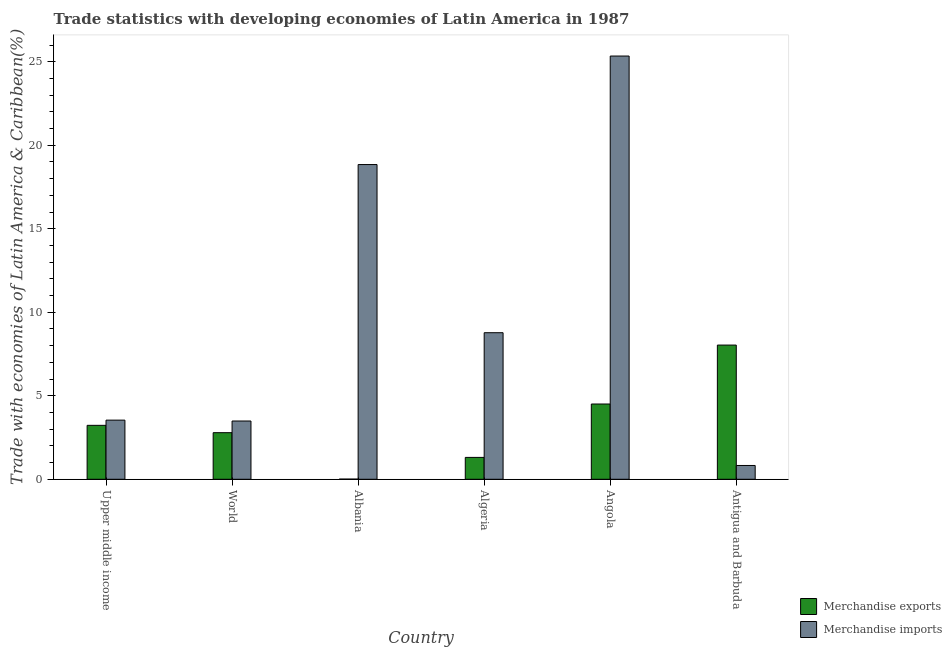How many different coloured bars are there?
Your answer should be very brief. 2. How many groups of bars are there?
Offer a terse response. 6. Are the number of bars per tick equal to the number of legend labels?
Provide a succinct answer. Yes. How many bars are there on the 2nd tick from the left?
Provide a succinct answer. 2. How many bars are there on the 6th tick from the right?
Provide a succinct answer. 2. What is the label of the 6th group of bars from the left?
Give a very brief answer. Antigua and Barbuda. What is the merchandise imports in Antigua and Barbuda?
Keep it short and to the point. 0.83. Across all countries, what is the maximum merchandise exports?
Offer a terse response. 8.04. Across all countries, what is the minimum merchandise exports?
Give a very brief answer. 0.01. In which country was the merchandise imports maximum?
Keep it short and to the point. Angola. In which country was the merchandise exports minimum?
Provide a short and direct response. Albania. What is the total merchandise exports in the graph?
Keep it short and to the point. 19.88. What is the difference between the merchandise exports in Angola and that in Antigua and Barbuda?
Make the answer very short. -3.53. What is the difference between the merchandise exports in Albania and the merchandise imports in World?
Provide a short and direct response. -3.48. What is the average merchandise exports per country?
Provide a succinct answer. 3.31. What is the difference between the merchandise imports and merchandise exports in Algeria?
Keep it short and to the point. 7.47. What is the ratio of the merchandise imports in Albania to that in Algeria?
Ensure brevity in your answer.  2.15. Is the difference between the merchandise exports in Algeria and Upper middle income greater than the difference between the merchandise imports in Algeria and Upper middle income?
Your response must be concise. No. What is the difference between the highest and the second highest merchandise imports?
Give a very brief answer. 6.5. What is the difference between the highest and the lowest merchandise imports?
Keep it short and to the point. 24.51. In how many countries, is the merchandise exports greater than the average merchandise exports taken over all countries?
Offer a very short reply. 2. What is the difference between two consecutive major ticks on the Y-axis?
Give a very brief answer. 5. Are the values on the major ticks of Y-axis written in scientific E-notation?
Your answer should be very brief. No. Does the graph contain grids?
Offer a very short reply. No. Where does the legend appear in the graph?
Your answer should be very brief. Bottom right. How many legend labels are there?
Your answer should be very brief. 2. What is the title of the graph?
Your response must be concise. Trade statistics with developing economies of Latin America in 1987. Does "Urban Population" appear as one of the legend labels in the graph?
Your answer should be compact. No. What is the label or title of the X-axis?
Keep it short and to the point. Country. What is the label or title of the Y-axis?
Offer a very short reply. Trade with economies of Latin America & Caribbean(%). What is the Trade with economies of Latin America & Caribbean(%) in Merchandise exports in Upper middle income?
Your response must be concise. 3.23. What is the Trade with economies of Latin America & Caribbean(%) in Merchandise imports in Upper middle income?
Your answer should be very brief. 3.54. What is the Trade with economies of Latin America & Caribbean(%) in Merchandise exports in World?
Your response must be concise. 2.79. What is the Trade with economies of Latin America & Caribbean(%) in Merchandise imports in World?
Offer a terse response. 3.49. What is the Trade with economies of Latin America & Caribbean(%) of Merchandise exports in Albania?
Offer a very short reply. 0.01. What is the Trade with economies of Latin America & Caribbean(%) of Merchandise imports in Albania?
Provide a succinct answer. 18.84. What is the Trade with economies of Latin America & Caribbean(%) in Merchandise exports in Algeria?
Give a very brief answer. 1.31. What is the Trade with economies of Latin America & Caribbean(%) in Merchandise imports in Algeria?
Offer a terse response. 8.77. What is the Trade with economies of Latin America & Caribbean(%) in Merchandise exports in Angola?
Offer a terse response. 4.51. What is the Trade with economies of Latin America & Caribbean(%) of Merchandise imports in Angola?
Make the answer very short. 25.34. What is the Trade with economies of Latin America & Caribbean(%) of Merchandise exports in Antigua and Barbuda?
Make the answer very short. 8.04. What is the Trade with economies of Latin America & Caribbean(%) in Merchandise imports in Antigua and Barbuda?
Make the answer very short. 0.83. Across all countries, what is the maximum Trade with economies of Latin America & Caribbean(%) of Merchandise exports?
Provide a succinct answer. 8.04. Across all countries, what is the maximum Trade with economies of Latin America & Caribbean(%) in Merchandise imports?
Your answer should be very brief. 25.34. Across all countries, what is the minimum Trade with economies of Latin America & Caribbean(%) in Merchandise exports?
Offer a terse response. 0.01. Across all countries, what is the minimum Trade with economies of Latin America & Caribbean(%) in Merchandise imports?
Keep it short and to the point. 0.83. What is the total Trade with economies of Latin America & Caribbean(%) in Merchandise exports in the graph?
Make the answer very short. 19.88. What is the total Trade with economies of Latin America & Caribbean(%) of Merchandise imports in the graph?
Ensure brevity in your answer.  60.81. What is the difference between the Trade with economies of Latin America & Caribbean(%) of Merchandise exports in Upper middle income and that in World?
Make the answer very short. 0.44. What is the difference between the Trade with economies of Latin America & Caribbean(%) in Merchandise imports in Upper middle income and that in World?
Offer a very short reply. 0.05. What is the difference between the Trade with economies of Latin America & Caribbean(%) of Merchandise exports in Upper middle income and that in Albania?
Your response must be concise. 3.22. What is the difference between the Trade with economies of Latin America & Caribbean(%) in Merchandise imports in Upper middle income and that in Albania?
Give a very brief answer. -15.3. What is the difference between the Trade with economies of Latin America & Caribbean(%) of Merchandise exports in Upper middle income and that in Algeria?
Offer a very short reply. 1.92. What is the difference between the Trade with economies of Latin America & Caribbean(%) of Merchandise imports in Upper middle income and that in Algeria?
Make the answer very short. -5.23. What is the difference between the Trade with economies of Latin America & Caribbean(%) in Merchandise exports in Upper middle income and that in Angola?
Your answer should be very brief. -1.28. What is the difference between the Trade with economies of Latin America & Caribbean(%) in Merchandise imports in Upper middle income and that in Angola?
Your answer should be very brief. -21.8. What is the difference between the Trade with economies of Latin America & Caribbean(%) of Merchandise exports in Upper middle income and that in Antigua and Barbuda?
Keep it short and to the point. -4.81. What is the difference between the Trade with economies of Latin America & Caribbean(%) in Merchandise imports in Upper middle income and that in Antigua and Barbuda?
Your answer should be compact. 2.71. What is the difference between the Trade with economies of Latin America & Caribbean(%) in Merchandise exports in World and that in Albania?
Give a very brief answer. 2.78. What is the difference between the Trade with economies of Latin America & Caribbean(%) in Merchandise imports in World and that in Albania?
Ensure brevity in your answer.  -15.35. What is the difference between the Trade with economies of Latin America & Caribbean(%) of Merchandise exports in World and that in Algeria?
Your answer should be very brief. 1.48. What is the difference between the Trade with economies of Latin America & Caribbean(%) in Merchandise imports in World and that in Algeria?
Ensure brevity in your answer.  -5.29. What is the difference between the Trade with economies of Latin America & Caribbean(%) of Merchandise exports in World and that in Angola?
Make the answer very short. -1.72. What is the difference between the Trade with economies of Latin America & Caribbean(%) in Merchandise imports in World and that in Angola?
Provide a short and direct response. -21.85. What is the difference between the Trade with economies of Latin America & Caribbean(%) of Merchandise exports in World and that in Antigua and Barbuda?
Your answer should be very brief. -5.25. What is the difference between the Trade with economies of Latin America & Caribbean(%) in Merchandise imports in World and that in Antigua and Barbuda?
Your answer should be very brief. 2.66. What is the difference between the Trade with economies of Latin America & Caribbean(%) in Merchandise exports in Albania and that in Algeria?
Provide a succinct answer. -1.3. What is the difference between the Trade with economies of Latin America & Caribbean(%) in Merchandise imports in Albania and that in Algeria?
Offer a terse response. 10.07. What is the difference between the Trade with economies of Latin America & Caribbean(%) in Merchandise exports in Albania and that in Angola?
Provide a short and direct response. -4.5. What is the difference between the Trade with economies of Latin America & Caribbean(%) in Merchandise imports in Albania and that in Angola?
Offer a terse response. -6.5. What is the difference between the Trade with economies of Latin America & Caribbean(%) in Merchandise exports in Albania and that in Antigua and Barbuda?
Ensure brevity in your answer.  -8.03. What is the difference between the Trade with economies of Latin America & Caribbean(%) of Merchandise imports in Albania and that in Antigua and Barbuda?
Your answer should be compact. 18.02. What is the difference between the Trade with economies of Latin America & Caribbean(%) of Merchandise exports in Algeria and that in Angola?
Provide a short and direct response. -3.2. What is the difference between the Trade with economies of Latin America & Caribbean(%) of Merchandise imports in Algeria and that in Angola?
Ensure brevity in your answer.  -16.57. What is the difference between the Trade with economies of Latin America & Caribbean(%) in Merchandise exports in Algeria and that in Antigua and Barbuda?
Your response must be concise. -6.73. What is the difference between the Trade with economies of Latin America & Caribbean(%) in Merchandise imports in Algeria and that in Antigua and Barbuda?
Make the answer very short. 7.95. What is the difference between the Trade with economies of Latin America & Caribbean(%) of Merchandise exports in Angola and that in Antigua and Barbuda?
Keep it short and to the point. -3.53. What is the difference between the Trade with economies of Latin America & Caribbean(%) in Merchandise imports in Angola and that in Antigua and Barbuda?
Provide a succinct answer. 24.51. What is the difference between the Trade with economies of Latin America & Caribbean(%) of Merchandise exports in Upper middle income and the Trade with economies of Latin America & Caribbean(%) of Merchandise imports in World?
Offer a terse response. -0.26. What is the difference between the Trade with economies of Latin America & Caribbean(%) of Merchandise exports in Upper middle income and the Trade with economies of Latin America & Caribbean(%) of Merchandise imports in Albania?
Your answer should be compact. -15.61. What is the difference between the Trade with economies of Latin America & Caribbean(%) in Merchandise exports in Upper middle income and the Trade with economies of Latin America & Caribbean(%) in Merchandise imports in Algeria?
Keep it short and to the point. -5.55. What is the difference between the Trade with economies of Latin America & Caribbean(%) of Merchandise exports in Upper middle income and the Trade with economies of Latin America & Caribbean(%) of Merchandise imports in Angola?
Keep it short and to the point. -22.11. What is the difference between the Trade with economies of Latin America & Caribbean(%) of Merchandise exports in Upper middle income and the Trade with economies of Latin America & Caribbean(%) of Merchandise imports in Antigua and Barbuda?
Offer a terse response. 2.4. What is the difference between the Trade with economies of Latin America & Caribbean(%) of Merchandise exports in World and the Trade with economies of Latin America & Caribbean(%) of Merchandise imports in Albania?
Offer a very short reply. -16.05. What is the difference between the Trade with economies of Latin America & Caribbean(%) of Merchandise exports in World and the Trade with economies of Latin America & Caribbean(%) of Merchandise imports in Algeria?
Provide a short and direct response. -5.99. What is the difference between the Trade with economies of Latin America & Caribbean(%) of Merchandise exports in World and the Trade with economies of Latin America & Caribbean(%) of Merchandise imports in Angola?
Offer a very short reply. -22.55. What is the difference between the Trade with economies of Latin America & Caribbean(%) in Merchandise exports in World and the Trade with economies of Latin America & Caribbean(%) in Merchandise imports in Antigua and Barbuda?
Your answer should be very brief. 1.96. What is the difference between the Trade with economies of Latin America & Caribbean(%) of Merchandise exports in Albania and the Trade with economies of Latin America & Caribbean(%) of Merchandise imports in Algeria?
Your answer should be compact. -8.76. What is the difference between the Trade with economies of Latin America & Caribbean(%) in Merchandise exports in Albania and the Trade with economies of Latin America & Caribbean(%) in Merchandise imports in Angola?
Offer a terse response. -25.33. What is the difference between the Trade with economies of Latin America & Caribbean(%) in Merchandise exports in Albania and the Trade with economies of Latin America & Caribbean(%) in Merchandise imports in Antigua and Barbuda?
Keep it short and to the point. -0.82. What is the difference between the Trade with economies of Latin America & Caribbean(%) in Merchandise exports in Algeria and the Trade with economies of Latin America & Caribbean(%) in Merchandise imports in Angola?
Provide a succinct answer. -24.03. What is the difference between the Trade with economies of Latin America & Caribbean(%) in Merchandise exports in Algeria and the Trade with economies of Latin America & Caribbean(%) in Merchandise imports in Antigua and Barbuda?
Keep it short and to the point. 0.48. What is the difference between the Trade with economies of Latin America & Caribbean(%) of Merchandise exports in Angola and the Trade with economies of Latin America & Caribbean(%) of Merchandise imports in Antigua and Barbuda?
Provide a succinct answer. 3.68. What is the average Trade with economies of Latin America & Caribbean(%) of Merchandise exports per country?
Your response must be concise. 3.31. What is the average Trade with economies of Latin America & Caribbean(%) in Merchandise imports per country?
Your answer should be very brief. 10.14. What is the difference between the Trade with economies of Latin America & Caribbean(%) of Merchandise exports and Trade with economies of Latin America & Caribbean(%) of Merchandise imports in Upper middle income?
Offer a very short reply. -0.31. What is the difference between the Trade with economies of Latin America & Caribbean(%) in Merchandise exports and Trade with economies of Latin America & Caribbean(%) in Merchandise imports in World?
Your response must be concise. -0.7. What is the difference between the Trade with economies of Latin America & Caribbean(%) of Merchandise exports and Trade with economies of Latin America & Caribbean(%) of Merchandise imports in Albania?
Ensure brevity in your answer.  -18.83. What is the difference between the Trade with economies of Latin America & Caribbean(%) of Merchandise exports and Trade with economies of Latin America & Caribbean(%) of Merchandise imports in Algeria?
Make the answer very short. -7.47. What is the difference between the Trade with economies of Latin America & Caribbean(%) in Merchandise exports and Trade with economies of Latin America & Caribbean(%) in Merchandise imports in Angola?
Provide a short and direct response. -20.83. What is the difference between the Trade with economies of Latin America & Caribbean(%) in Merchandise exports and Trade with economies of Latin America & Caribbean(%) in Merchandise imports in Antigua and Barbuda?
Your response must be concise. 7.21. What is the ratio of the Trade with economies of Latin America & Caribbean(%) of Merchandise exports in Upper middle income to that in World?
Make the answer very short. 1.16. What is the ratio of the Trade with economies of Latin America & Caribbean(%) in Merchandise imports in Upper middle income to that in World?
Give a very brief answer. 1.01. What is the ratio of the Trade with economies of Latin America & Caribbean(%) of Merchandise exports in Upper middle income to that in Albania?
Provide a succinct answer. 320.57. What is the ratio of the Trade with economies of Latin America & Caribbean(%) of Merchandise imports in Upper middle income to that in Albania?
Provide a succinct answer. 0.19. What is the ratio of the Trade with economies of Latin America & Caribbean(%) of Merchandise exports in Upper middle income to that in Algeria?
Make the answer very short. 2.47. What is the ratio of the Trade with economies of Latin America & Caribbean(%) of Merchandise imports in Upper middle income to that in Algeria?
Provide a short and direct response. 0.4. What is the ratio of the Trade with economies of Latin America & Caribbean(%) of Merchandise exports in Upper middle income to that in Angola?
Offer a very short reply. 0.72. What is the ratio of the Trade with economies of Latin America & Caribbean(%) in Merchandise imports in Upper middle income to that in Angola?
Give a very brief answer. 0.14. What is the ratio of the Trade with economies of Latin America & Caribbean(%) in Merchandise exports in Upper middle income to that in Antigua and Barbuda?
Your response must be concise. 0.4. What is the ratio of the Trade with economies of Latin America & Caribbean(%) in Merchandise imports in Upper middle income to that in Antigua and Barbuda?
Provide a short and direct response. 4.28. What is the ratio of the Trade with economies of Latin America & Caribbean(%) of Merchandise exports in World to that in Albania?
Provide a short and direct response. 276.93. What is the ratio of the Trade with economies of Latin America & Caribbean(%) of Merchandise imports in World to that in Albania?
Provide a succinct answer. 0.19. What is the ratio of the Trade with economies of Latin America & Caribbean(%) in Merchandise exports in World to that in Algeria?
Ensure brevity in your answer.  2.13. What is the ratio of the Trade with economies of Latin America & Caribbean(%) of Merchandise imports in World to that in Algeria?
Give a very brief answer. 0.4. What is the ratio of the Trade with economies of Latin America & Caribbean(%) of Merchandise exports in World to that in Angola?
Ensure brevity in your answer.  0.62. What is the ratio of the Trade with economies of Latin America & Caribbean(%) in Merchandise imports in World to that in Angola?
Give a very brief answer. 0.14. What is the ratio of the Trade with economies of Latin America & Caribbean(%) in Merchandise exports in World to that in Antigua and Barbuda?
Give a very brief answer. 0.35. What is the ratio of the Trade with economies of Latin America & Caribbean(%) in Merchandise imports in World to that in Antigua and Barbuda?
Ensure brevity in your answer.  4.22. What is the ratio of the Trade with economies of Latin America & Caribbean(%) in Merchandise exports in Albania to that in Algeria?
Give a very brief answer. 0.01. What is the ratio of the Trade with economies of Latin America & Caribbean(%) of Merchandise imports in Albania to that in Algeria?
Provide a short and direct response. 2.15. What is the ratio of the Trade with economies of Latin America & Caribbean(%) in Merchandise exports in Albania to that in Angola?
Provide a short and direct response. 0. What is the ratio of the Trade with economies of Latin America & Caribbean(%) of Merchandise imports in Albania to that in Angola?
Offer a terse response. 0.74. What is the ratio of the Trade with economies of Latin America & Caribbean(%) in Merchandise exports in Albania to that in Antigua and Barbuda?
Offer a terse response. 0. What is the ratio of the Trade with economies of Latin America & Caribbean(%) in Merchandise imports in Albania to that in Antigua and Barbuda?
Ensure brevity in your answer.  22.8. What is the ratio of the Trade with economies of Latin America & Caribbean(%) in Merchandise exports in Algeria to that in Angola?
Your answer should be compact. 0.29. What is the ratio of the Trade with economies of Latin America & Caribbean(%) in Merchandise imports in Algeria to that in Angola?
Give a very brief answer. 0.35. What is the ratio of the Trade with economies of Latin America & Caribbean(%) of Merchandise exports in Algeria to that in Antigua and Barbuda?
Your answer should be compact. 0.16. What is the ratio of the Trade with economies of Latin America & Caribbean(%) in Merchandise imports in Algeria to that in Antigua and Barbuda?
Give a very brief answer. 10.62. What is the ratio of the Trade with economies of Latin America & Caribbean(%) in Merchandise exports in Angola to that in Antigua and Barbuda?
Ensure brevity in your answer.  0.56. What is the ratio of the Trade with economies of Latin America & Caribbean(%) in Merchandise imports in Angola to that in Antigua and Barbuda?
Offer a very short reply. 30.67. What is the difference between the highest and the second highest Trade with economies of Latin America & Caribbean(%) of Merchandise exports?
Keep it short and to the point. 3.53. What is the difference between the highest and the second highest Trade with economies of Latin America & Caribbean(%) in Merchandise imports?
Give a very brief answer. 6.5. What is the difference between the highest and the lowest Trade with economies of Latin America & Caribbean(%) of Merchandise exports?
Offer a very short reply. 8.03. What is the difference between the highest and the lowest Trade with economies of Latin America & Caribbean(%) in Merchandise imports?
Give a very brief answer. 24.51. 